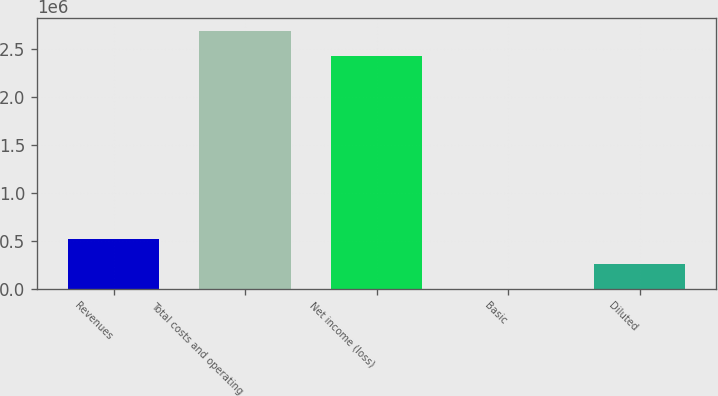Convert chart to OTSL. <chart><loc_0><loc_0><loc_500><loc_500><bar_chart><fcel>Revenues<fcel>Total costs and operating<fcel>Net income (loss)<fcel>Basic<fcel>Diluted<nl><fcel>515440<fcel>2.69322e+06<fcel>2.43551e+06<fcel>23.59<fcel>257732<nl></chart> 